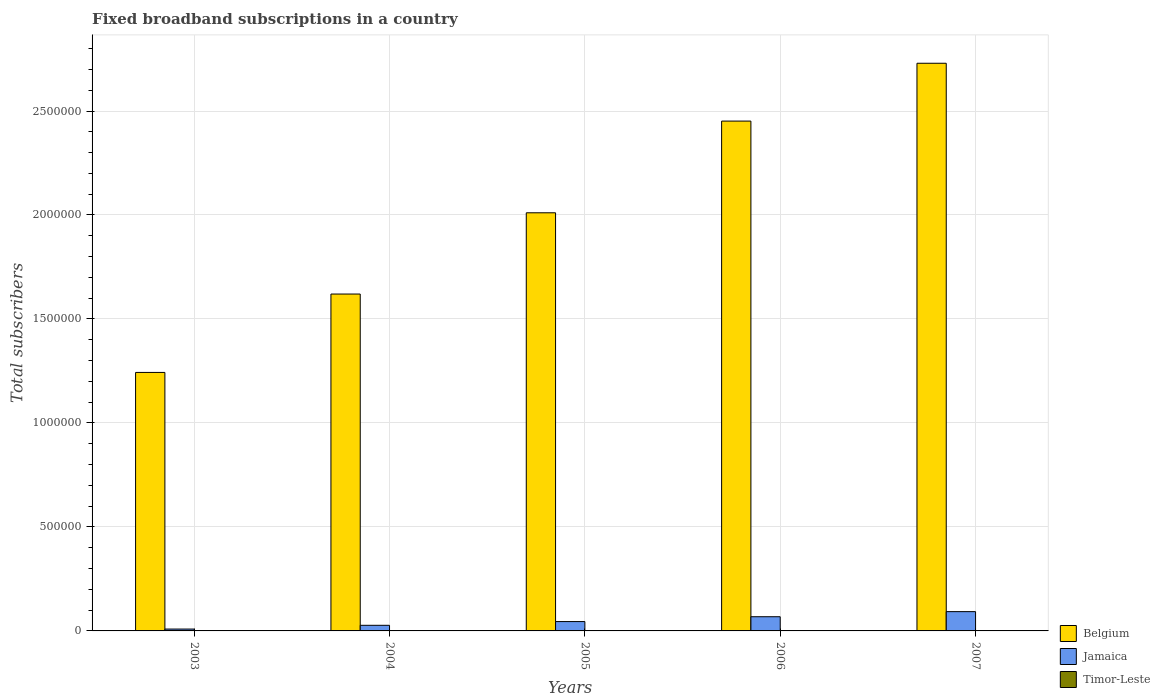How many groups of bars are there?
Your response must be concise. 5. How many bars are there on the 1st tick from the left?
Your answer should be compact. 3. What is the label of the 4th group of bars from the left?
Your answer should be very brief. 2006. What is the number of broadband subscriptions in Belgium in 2004?
Provide a short and direct response. 1.62e+06. Across all years, what is the maximum number of broadband subscriptions in Belgium?
Provide a succinct answer. 2.73e+06. Across all years, what is the minimum number of broadband subscriptions in Jamaica?
Give a very brief answer. 9000. In which year was the number of broadband subscriptions in Timor-Leste minimum?
Offer a very short reply. 2003. What is the total number of broadband subscriptions in Timor-Leste in the graph?
Keep it short and to the point. 123. What is the difference between the number of broadband subscriptions in Jamaica in 2003 and that in 2006?
Ensure brevity in your answer.  -5.92e+04. What is the difference between the number of broadband subscriptions in Jamaica in 2007 and the number of broadband subscriptions in Timor-Leste in 2005?
Provide a succinct answer. 9.27e+04. What is the average number of broadband subscriptions in Timor-Leste per year?
Your answer should be very brief. 24.6. In the year 2006, what is the difference between the number of broadband subscriptions in Timor-Leste and number of broadband subscriptions in Jamaica?
Provide a short and direct response. -6.82e+04. What is the ratio of the number of broadband subscriptions in Belgium in 2005 to that in 2006?
Your answer should be very brief. 0.82. Is the number of broadband subscriptions in Jamaica in 2003 less than that in 2005?
Your answer should be very brief. Yes. Is the difference between the number of broadband subscriptions in Timor-Leste in 2006 and 2007 greater than the difference between the number of broadband subscriptions in Jamaica in 2006 and 2007?
Make the answer very short. Yes. What is the difference between the highest and the second highest number of broadband subscriptions in Timor-Leste?
Your answer should be compact. 21. What is the difference between the highest and the lowest number of broadband subscriptions in Jamaica?
Offer a terse response. 8.38e+04. In how many years, is the number of broadband subscriptions in Jamaica greater than the average number of broadband subscriptions in Jamaica taken over all years?
Give a very brief answer. 2. Is the sum of the number of broadband subscriptions in Jamaica in 2003 and 2007 greater than the maximum number of broadband subscriptions in Timor-Leste across all years?
Keep it short and to the point. Yes. What does the 2nd bar from the left in 2007 represents?
Provide a short and direct response. Jamaica. What does the 2nd bar from the right in 2003 represents?
Provide a succinct answer. Jamaica. How many bars are there?
Offer a very short reply. 15. What is the difference between two consecutive major ticks on the Y-axis?
Your answer should be very brief. 5.00e+05. Are the values on the major ticks of Y-axis written in scientific E-notation?
Offer a very short reply. No. Where does the legend appear in the graph?
Your answer should be compact. Bottom right. How many legend labels are there?
Your answer should be very brief. 3. How are the legend labels stacked?
Ensure brevity in your answer.  Vertical. What is the title of the graph?
Keep it short and to the point. Fixed broadband subscriptions in a country. Does "Liechtenstein" appear as one of the legend labels in the graph?
Make the answer very short. No. What is the label or title of the X-axis?
Provide a succinct answer. Years. What is the label or title of the Y-axis?
Offer a terse response. Total subscribers. What is the Total subscribers in Belgium in 2003?
Your answer should be very brief. 1.24e+06. What is the Total subscribers of Jamaica in 2003?
Provide a succinct answer. 9000. What is the Total subscribers of Timor-Leste in 2003?
Your response must be concise. 9. What is the Total subscribers of Belgium in 2004?
Ensure brevity in your answer.  1.62e+06. What is the Total subscribers of Jamaica in 2004?
Your answer should be very brief. 2.70e+04. What is the Total subscribers of Belgium in 2005?
Give a very brief answer. 2.01e+06. What is the Total subscribers in Jamaica in 2005?
Provide a short and direct response. 4.50e+04. What is the Total subscribers of Timor-Leste in 2005?
Keep it short and to the point. 22. What is the Total subscribers in Belgium in 2006?
Your response must be concise. 2.45e+06. What is the Total subscribers of Jamaica in 2006?
Provide a succinct answer. 6.82e+04. What is the Total subscribers in Belgium in 2007?
Offer a terse response. 2.73e+06. What is the Total subscribers of Jamaica in 2007?
Provide a short and direct response. 9.28e+04. Across all years, what is the maximum Total subscribers in Belgium?
Keep it short and to the point. 2.73e+06. Across all years, what is the maximum Total subscribers in Jamaica?
Keep it short and to the point. 9.28e+04. Across all years, what is the maximum Total subscribers in Timor-Leste?
Make the answer very short. 50. Across all years, what is the minimum Total subscribers in Belgium?
Make the answer very short. 1.24e+06. Across all years, what is the minimum Total subscribers of Jamaica?
Your answer should be very brief. 9000. Across all years, what is the minimum Total subscribers of Timor-Leste?
Your answer should be compact. 9. What is the total Total subscribers of Belgium in the graph?
Make the answer very short. 1.01e+07. What is the total Total subscribers in Jamaica in the graph?
Your answer should be very brief. 2.42e+05. What is the total Total subscribers in Timor-Leste in the graph?
Offer a terse response. 123. What is the difference between the Total subscribers in Belgium in 2003 and that in 2004?
Give a very brief answer. -3.77e+05. What is the difference between the Total subscribers in Jamaica in 2003 and that in 2004?
Offer a terse response. -1.80e+04. What is the difference between the Total subscribers of Timor-Leste in 2003 and that in 2004?
Ensure brevity in your answer.  -4. What is the difference between the Total subscribers in Belgium in 2003 and that in 2005?
Make the answer very short. -7.68e+05. What is the difference between the Total subscribers in Jamaica in 2003 and that in 2005?
Provide a short and direct response. -3.60e+04. What is the difference between the Total subscribers of Timor-Leste in 2003 and that in 2005?
Offer a terse response. -13. What is the difference between the Total subscribers of Belgium in 2003 and that in 2006?
Offer a terse response. -1.21e+06. What is the difference between the Total subscribers in Jamaica in 2003 and that in 2006?
Give a very brief answer. -5.92e+04. What is the difference between the Total subscribers of Timor-Leste in 2003 and that in 2006?
Your answer should be compact. -20. What is the difference between the Total subscribers in Belgium in 2003 and that in 2007?
Ensure brevity in your answer.  -1.49e+06. What is the difference between the Total subscribers in Jamaica in 2003 and that in 2007?
Keep it short and to the point. -8.38e+04. What is the difference between the Total subscribers of Timor-Leste in 2003 and that in 2007?
Give a very brief answer. -41. What is the difference between the Total subscribers in Belgium in 2004 and that in 2005?
Keep it short and to the point. -3.91e+05. What is the difference between the Total subscribers in Jamaica in 2004 and that in 2005?
Your answer should be compact. -1.80e+04. What is the difference between the Total subscribers of Timor-Leste in 2004 and that in 2005?
Provide a short and direct response. -9. What is the difference between the Total subscribers of Belgium in 2004 and that in 2006?
Make the answer very short. -8.32e+05. What is the difference between the Total subscribers in Jamaica in 2004 and that in 2006?
Give a very brief answer. -4.12e+04. What is the difference between the Total subscribers in Timor-Leste in 2004 and that in 2006?
Offer a very short reply. -16. What is the difference between the Total subscribers in Belgium in 2004 and that in 2007?
Keep it short and to the point. -1.11e+06. What is the difference between the Total subscribers of Jamaica in 2004 and that in 2007?
Offer a terse response. -6.58e+04. What is the difference between the Total subscribers of Timor-Leste in 2004 and that in 2007?
Give a very brief answer. -37. What is the difference between the Total subscribers in Belgium in 2005 and that in 2006?
Make the answer very short. -4.41e+05. What is the difference between the Total subscribers of Jamaica in 2005 and that in 2006?
Provide a short and direct response. -2.32e+04. What is the difference between the Total subscribers of Belgium in 2005 and that in 2007?
Offer a very short reply. -7.19e+05. What is the difference between the Total subscribers in Jamaica in 2005 and that in 2007?
Keep it short and to the point. -4.78e+04. What is the difference between the Total subscribers of Timor-Leste in 2005 and that in 2007?
Provide a short and direct response. -28. What is the difference between the Total subscribers of Belgium in 2006 and that in 2007?
Offer a very short reply. -2.78e+05. What is the difference between the Total subscribers in Jamaica in 2006 and that in 2007?
Ensure brevity in your answer.  -2.45e+04. What is the difference between the Total subscribers of Belgium in 2003 and the Total subscribers of Jamaica in 2004?
Your answer should be very brief. 1.22e+06. What is the difference between the Total subscribers of Belgium in 2003 and the Total subscribers of Timor-Leste in 2004?
Give a very brief answer. 1.24e+06. What is the difference between the Total subscribers in Jamaica in 2003 and the Total subscribers in Timor-Leste in 2004?
Provide a succinct answer. 8987. What is the difference between the Total subscribers in Belgium in 2003 and the Total subscribers in Jamaica in 2005?
Your answer should be compact. 1.20e+06. What is the difference between the Total subscribers of Belgium in 2003 and the Total subscribers of Timor-Leste in 2005?
Ensure brevity in your answer.  1.24e+06. What is the difference between the Total subscribers in Jamaica in 2003 and the Total subscribers in Timor-Leste in 2005?
Keep it short and to the point. 8978. What is the difference between the Total subscribers of Belgium in 2003 and the Total subscribers of Jamaica in 2006?
Your answer should be compact. 1.17e+06. What is the difference between the Total subscribers of Belgium in 2003 and the Total subscribers of Timor-Leste in 2006?
Provide a succinct answer. 1.24e+06. What is the difference between the Total subscribers of Jamaica in 2003 and the Total subscribers of Timor-Leste in 2006?
Provide a short and direct response. 8971. What is the difference between the Total subscribers of Belgium in 2003 and the Total subscribers of Jamaica in 2007?
Provide a short and direct response. 1.15e+06. What is the difference between the Total subscribers of Belgium in 2003 and the Total subscribers of Timor-Leste in 2007?
Your answer should be compact. 1.24e+06. What is the difference between the Total subscribers of Jamaica in 2003 and the Total subscribers of Timor-Leste in 2007?
Provide a succinct answer. 8950. What is the difference between the Total subscribers of Belgium in 2004 and the Total subscribers of Jamaica in 2005?
Give a very brief answer. 1.57e+06. What is the difference between the Total subscribers of Belgium in 2004 and the Total subscribers of Timor-Leste in 2005?
Provide a short and direct response. 1.62e+06. What is the difference between the Total subscribers in Jamaica in 2004 and the Total subscribers in Timor-Leste in 2005?
Ensure brevity in your answer.  2.70e+04. What is the difference between the Total subscribers of Belgium in 2004 and the Total subscribers of Jamaica in 2006?
Offer a very short reply. 1.55e+06. What is the difference between the Total subscribers in Belgium in 2004 and the Total subscribers in Timor-Leste in 2006?
Your answer should be compact. 1.62e+06. What is the difference between the Total subscribers of Jamaica in 2004 and the Total subscribers of Timor-Leste in 2006?
Ensure brevity in your answer.  2.70e+04. What is the difference between the Total subscribers in Belgium in 2004 and the Total subscribers in Jamaica in 2007?
Provide a short and direct response. 1.53e+06. What is the difference between the Total subscribers of Belgium in 2004 and the Total subscribers of Timor-Leste in 2007?
Offer a terse response. 1.62e+06. What is the difference between the Total subscribers in Jamaica in 2004 and the Total subscribers in Timor-Leste in 2007?
Offer a very short reply. 2.70e+04. What is the difference between the Total subscribers of Belgium in 2005 and the Total subscribers of Jamaica in 2006?
Keep it short and to the point. 1.94e+06. What is the difference between the Total subscribers of Belgium in 2005 and the Total subscribers of Timor-Leste in 2006?
Offer a very short reply. 2.01e+06. What is the difference between the Total subscribers of Jamaica in 2005 and the Total subscribers of Timor-Leste in 2006?
Keep it short and to the point. 4.50e+04. What is the difference between the Total subscribers in Belgium in 2005 and the Total subscribers in Jamaica in 2007?
Provide a short and direct response. 1.92e+06. What is the difference between the Total subscribers in Belgium in 2005 and the Total subscribers in Timor-Leste in 2007?
Provide a succinct answer. 2.01e+06. What is the difference between the Total subscribers of Jamaica in 2005 and the Total subscribers of Timor-Leste in 2007?
Provide a succinct answer. 4.50e+04. What is the difference between the Total subscribers of Belgium in 2006 and the Total subscribers of Jamaica in 2007?
Make the answer very short. 2.36e+06. What is the difference between the Total subscribers of Belgium in 2006 and the Total subscribers of Timor-Leste in 2007?
Provide a succinct answer. 2.45e+06. What is the difference between the Total subscribers of Jamaica in 2006 and the Total subscribers of Timor-Leste in 2007?
Your response must be concise. 6.82e+04. What is the average Total subscribers of Belgium per year?
Give a very brief answer. 2.01e+06. What is the average Total subscribers in Jamaica per year?
Your answer should be compact. 4.84e+04. What is the average Total subscribers of Timor-Leste per year?
Offer a very short reply. 24.6. In the year 2003, what is the difference between the Total subscribers of Belgium and Total subscribers of Jamaica?
Ensure brevity in your answer.  1.23e+06. In the year 2003, what is the difference between the Total subscribers in Belgium and Total subscribers in Timor-Leste?
Provide a succinct answer. 1.24e+06. In the year 2003, what is the difference between the Total subscribers of Jamaica and Total subscribers of Timor-Leste?
Ensure brevity in your answer.  8991. In the year 2004, what is the difference between the Total subscribers of Belgium and Total subscribers of Jamaica?
Ensure brevity in your answer.  1.59e+06. In the year 2004, what is the difference between the Total subscribers in Belgium and Total subscribers in Timor-Leste?
Ensure brevity in your answer.  1.62e+06. In the year 2004, what is the difference between the Total subscribers of Jamaica and Total subscribers of Timor-Leste?
Ensure brevity in your answer.  2.70e+04. In the year 2005, what is the difference between the Total subscribers of Belgium and Total subscribers of Jamaica?
Offer a very short reply. 1.97e+06. In the year 2005, what is the difference between the Total subscribers of Belgium and Total subscribers of Timor-Leste?
Give a very brief answer. 2.01e+06. In the year 2005, what is the difference between the Total subscribers in Jamaica and Total subscribers in Timor-Leste?
Ensure brevity in your answer.  4.50e+04. In the year 2006, what is the difference between the Total subscribers in Belgium and Total subscribers in Jamaica?
Give a very brief answer. 2.38e+06. In the year 2006, what is the difference between the Total subscribers in Belgium and Total subscribers in Timor-Leste?
Your answer should be very brief. 2.45e+06. In the year 2006, what is the difference between the Total subscribers in Jamaica and Total subscribers in Timor-Leste?
Offer a terse response. 6.82e+04. In the year 2007, what is the difference between the Total subscribers in Belgium and Total subscribers in Jamaica?
Provide a short and direct response. 2.64e+06. In the year 2007, what is the difference between the Total subscribers of Belgium and Total subscribers of Timor-Leste?
Provide a short and direct response. 2.73e+06. In the year 2007, what is the difference between the Total subscribers of Jamaica and Total subscribers of Timor-Leste?
Give a very brief answer. 9.27e+04. What is the ratio of the Total subscribers of Belgium in 2003 to that in 2004?
Offer a terse response. 0.77. What is the ratio of the Total subscribers of Timor-Leste in 2003 to that in 2004?
Your response must be concise. 0.69. What is the ratio of the Total subscribers of Belgium in 2003 to that in 2005?
Offer a terse response. 0.62. What is the ratio of the Total subscribers of Jamaica in 2003 to that in 2005?
Provide a short and direct response. 0.2. What is the ratio of the Total subscribers in Timor-Leste in 2003 to that in 2005?
Your answer should be compact. 0.41. What is the ratio of the Total subscribers in Belgium in 2003 to that in 2006?
Make the answer very short. 0.51. What is the ratio of the Total subscribers of Jamaica in 2003 to that in 2006?
Ensure brevity in your answer.  0.13. What is the ratio of the Total subscribers of Timor-Leste in 2003 to that in 2006?
Provide a succinct answer. 0.31. What is the ratio of the Total subscribers in Belgium in 2003 to that in 2007?
Give a very brief answer. 0.46. What is the ratio of the Total subscribers of Jamaica in 2003 to that in 2007?
Offer a very short reply. 0.1. What is the ratio of the Total subscribers of Timor-Leste in 2003 to that in 2007?
Offer a very short reply. 0.18. What is the ratio of the Total subscribers of Belgium in 2004 to that in 2005?
Provide a succinct answer. 0.81. What is the ratio of the Total subscribers of Timor-Leste in 2004 to that in 2005?
Keep it short and to the point. 0.59. What is the ratio of the Total subscribers in Belgium in 2004 to that in 2006?
Your response must be concise. 0.66. What is the ratio of the Total subscribers in Jamaica in 2004 to that in 2006?
Give a very brief answer. 0.4. What is the ratio of the Total subscribers of Timor-Leste in 2004 to that in 2006?
Your answer should be compact. 0.45. What is the ratio of the Total subscribers in Belgium in 2004 to that in 2007?
Your answer should be compact. 0.59. What is the ratio of the Total subscribers in Jamaica in 2004 to that in 2007?
Provide a succinct answer. 0.29. What is the ratio of the Total subscribers in Timor-Leste in 2004 to that in 2007?
Provide a short and direct response. 0.26. What is the ratio of the Total subscribers in Belgium in 2005 to that in 2006?
Your response must be concise. 0.82. What is the ratio of the Total subscribers in Jamaica in 2005 to that in 2006?
Make the answer very short. 0.66. What is the ratio of the Total subscribers in Timor-Leste in 2005 to that in 2006?
Give a very brief answer. 0.76. What is the ratio of the Total subscribers of Belgium in 2005 to that in 2007?
Offer a terse response. 0.74. What is the ratio of the Total subscribers in Jamaica in 2005 to that in 2007?
Offer a terse response. 0.49. What is the ratio of the Total subscribers in Timor-Leste in 2005 to that in 2007?
Your answer should be compact. 0.44. What is the ratio of the Total subscribers in Belgium in 2006 to that in 2007?
Provide a succinct answer. 0.9. What is the ratio of the Total subscribers of Jamaica in 2006 to that in 2007?
Ensure brevity in your answer.  0.74. What is the ratio of the Total subscribers of Timor-Leste in 2006 to that in 2007?
Offer a very short reply. 0.58. What is the difference between the highest and the second highest Total subscribers in Belgium?
Provide a short and direct response. 2.78e+05. What is the difference between the highest and the second highest Total subscribers in Jamaica?
Make the answer very short. 2.45e+04. What is the difference between the highest and the second highest Total subscribers of Timor-Leste?
Provide a succinct answer. 21. What is the difference between the highest and the lowest Total subscribers of Belgium?
Provide a short and direct response. 1.49e+06. What is the difference between the highest and the lowest Total subscribers in Jamaica?
Your answer should be compact. 8.38e+04. What is the difference between the highest and the lowest Total subscribers of Timor-Leste?
Your response must be concise. 41. 